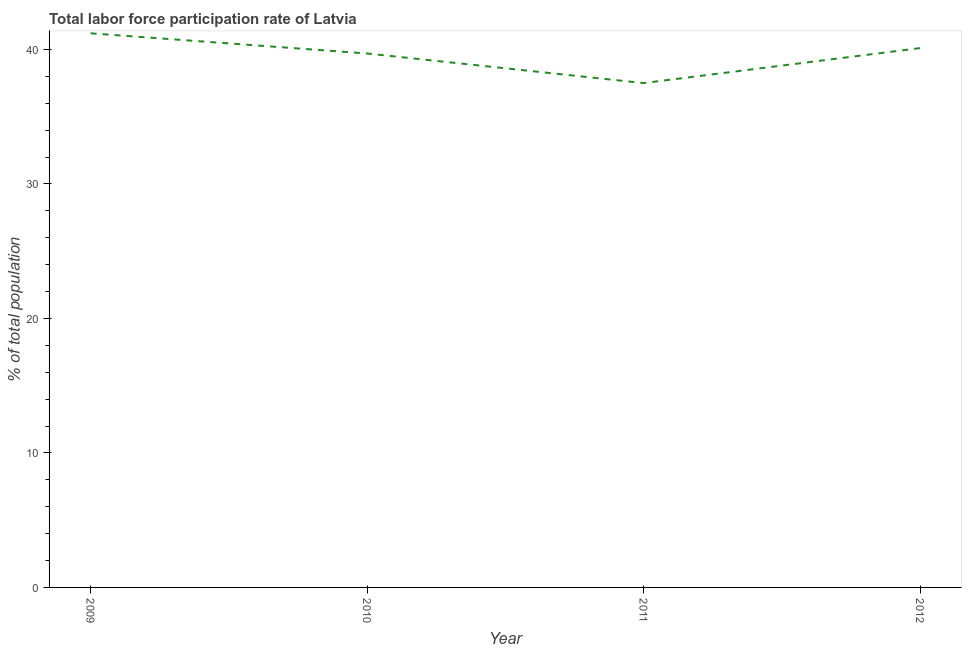What is the total labor force participation rate in 2011?
Offer a terse response. 37.5. Across all years, what is the maximum total labor force participation rate?
Make the answer very short. 41.2. Across all years, what is the minimum total labor force participation rate?
Your response must be concise. 37.5. In which year was the total labor force participation rate maximum?
Provide a succinct answer. 2009. What is the sum of the total labor force participation rate?
Ensure brevity in your answer.  158.5. What is the difference between the total labor force participation rate in 2011 and 2012?
Your answer should be compact. -2.6. What is the average total labor force participation rate per year?
Offer a terse response. 39.63. What is the median total labor force participation rate?
Provide a short and direct response. 39.9. What is the ratio of the total labor force participation rate in 2009 to that in 2010?
Your answer should be compact. 1.04. Is the total labor force participation rate in 2010 less than that in 2011?
Offer a terse response. No. What is the difference between the highest and the second highest total labor force participation rate?
Provide a succinct answer. 1.1. Is the sum of the total labor force participation rate in 2009 and 2010 greater than the maximum total labor force participation rate across all years?
Ensure brevity in your answer.  Yes. What is the difference between the highest and the lowest total labor force participation rate?
Your answer should be compact. 3.7. Does the total labor force participation rate monotonically increase over the years?
Your answer should be very brief. No. How many years are there in the graph?
Offer a terse response. 4. Does the graph contain grids?
Your answer should be very brief. No. What is the title of the graph?
Offer a very short reply. Total labor force participation rate of Latvia. What is the label or title of the Y-axis?
Give a very brief answer. % of total population. What is the % of total population in 2009?
Give a very brief answer. 41.2. What is the % of total population in 2010?
Offer a very short reply. 39.7. What is the % of total population in 2011?
Ensure brevity in your answer.  37.5. What is the % of total population of 2012?
Your answer should be very brief. 40.1. What is the difference between the % of total population in 2010 and 2011?
Make the answer very short. 2.2. What is the difference between the % of total population in 2011 and 2012?
Give a very brief answer. -2.6. What is the ratio of the % of total population in 2009 to that in 2010?
Make the answer very short. 1.04. What is the ratio of the % of total population in 2009 to that in 2011?
Your response must be concise. 1.1. What is the ratio of the % of total population in 2009 to that in 2012?
Give a very brief answer. 1.03. What is the ratio of the % of total population in 2010 to that in 2011?
Your answer should be compact. 1.06. What is the ratio of the % of total population in 2011 to that in 2012?
Your response must be concise. 0.94. 